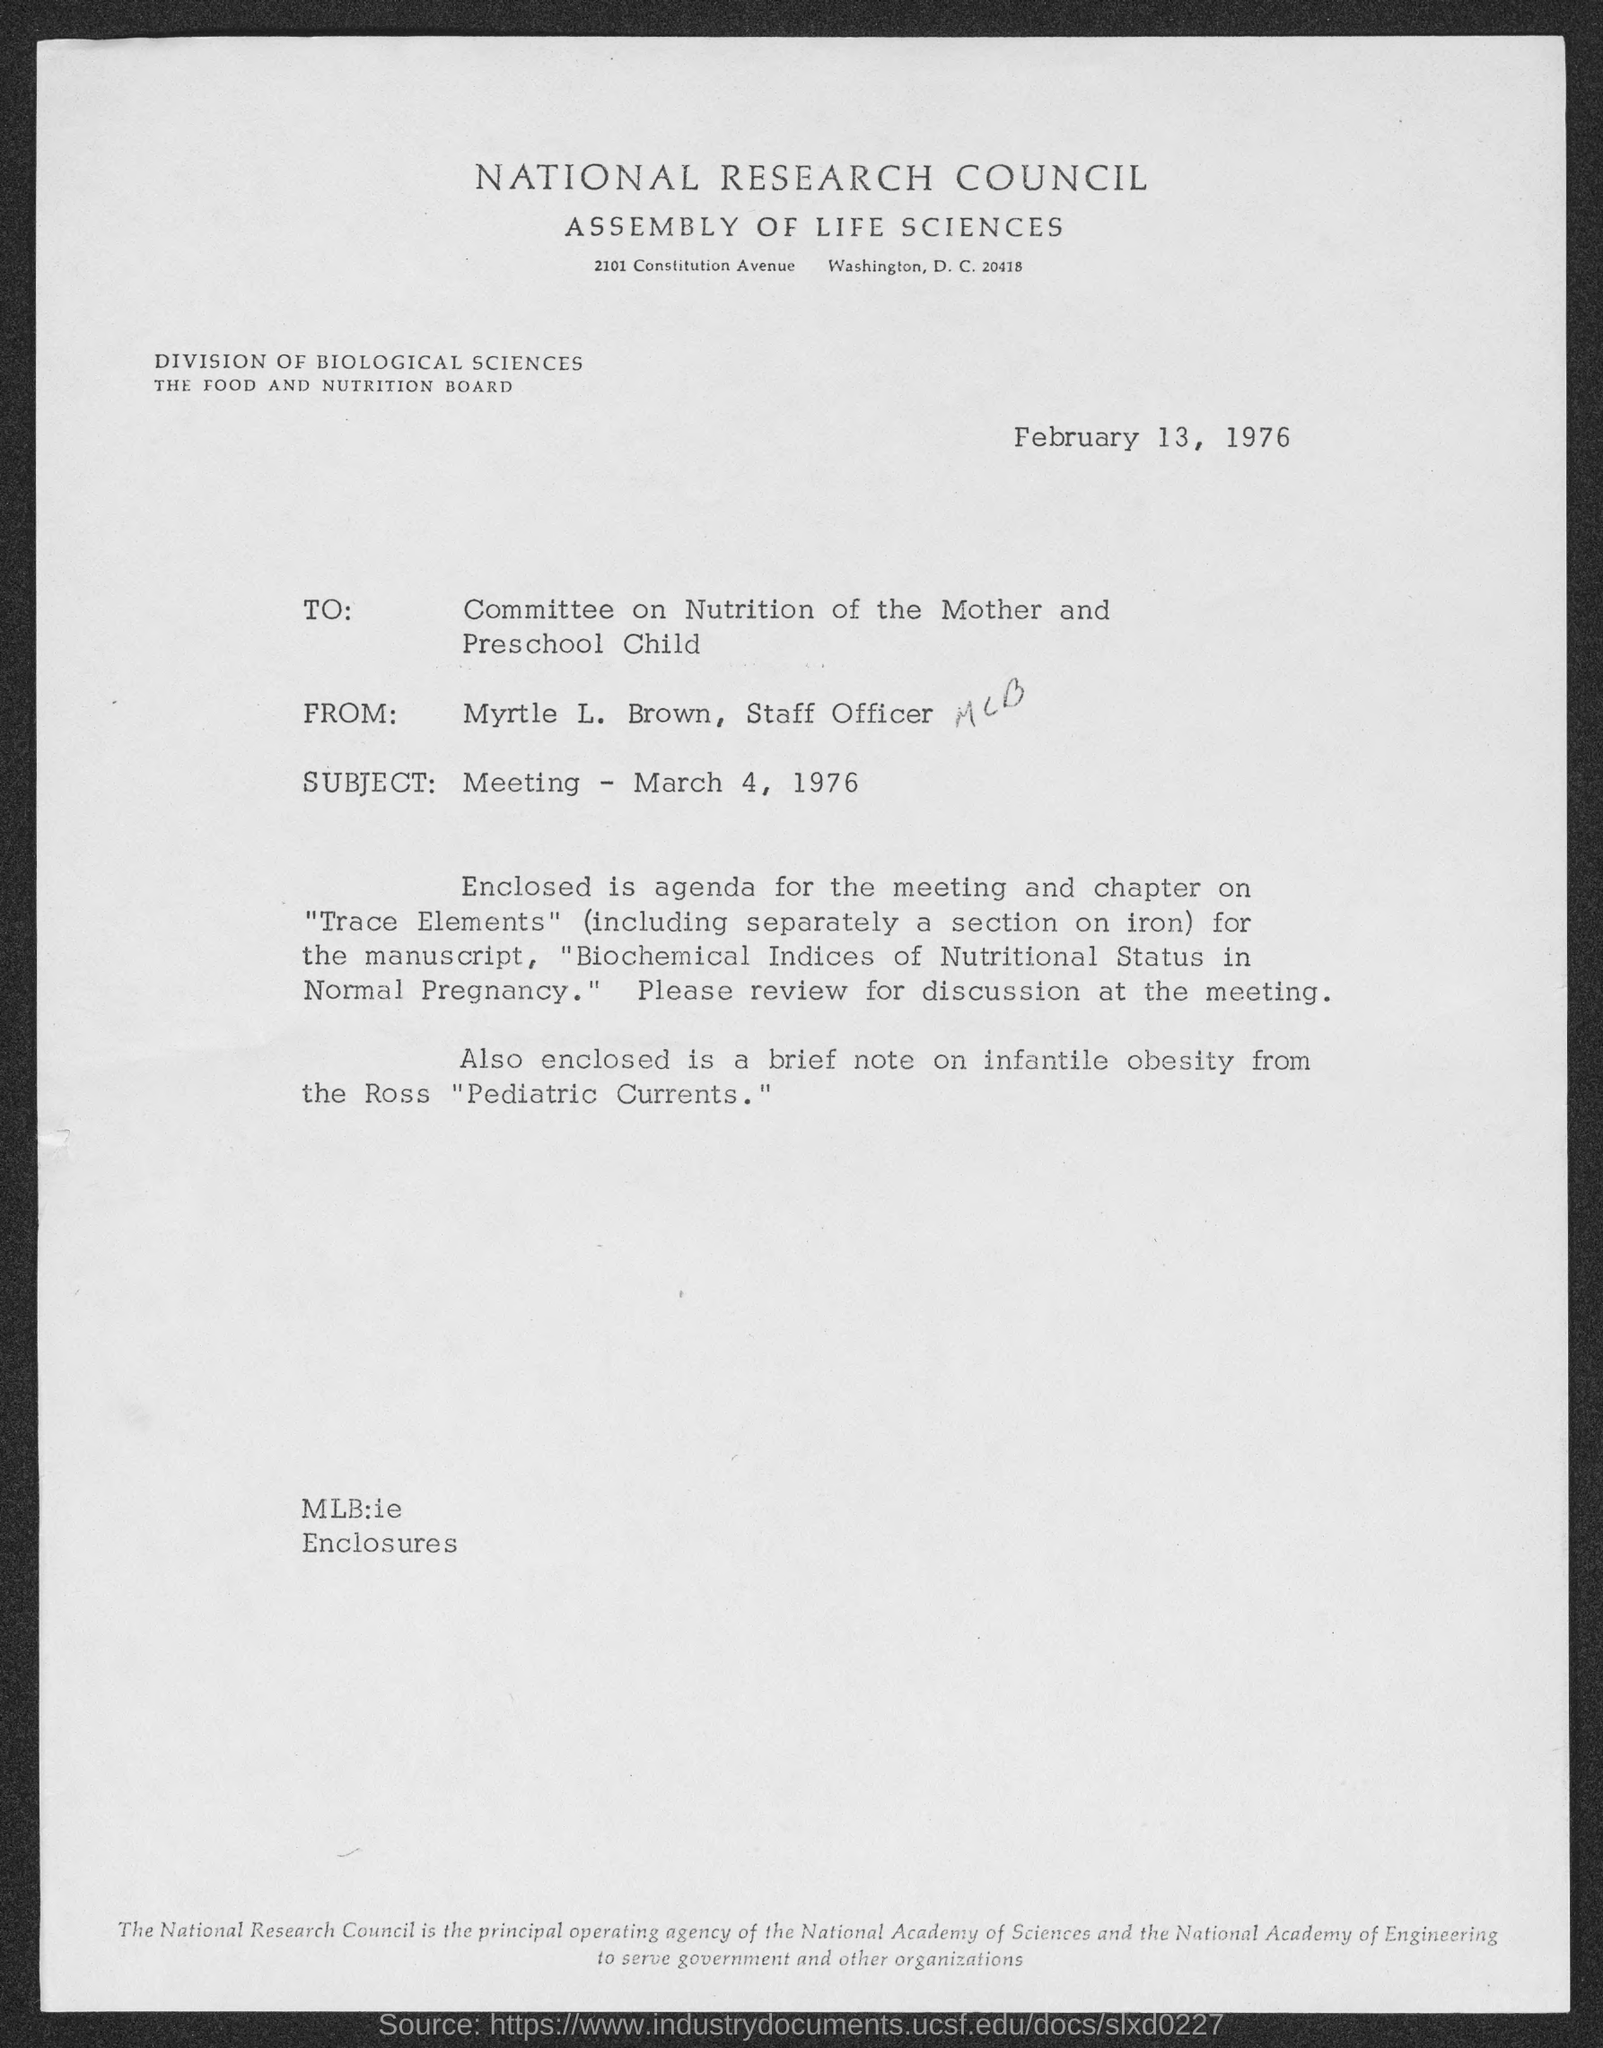What is the date mentioned in this letter?
Offer a very short reply. February 13, 1976. Which Council is mentioned in the letterhead?
Offer a terse response. NATIONAL RESEARCH COUNCIL. To whom, the letter is addressed?
Provide a succinct answer. Committee on Nutrition of the Mother and Preschool Child. Who is the sender of this letter?
Provide a short and direct response. Myrtle l. brown, staff officer. What is the subject mentioned in this letter?
Provide a succinct answer. Meeting - March 4, 1976. 